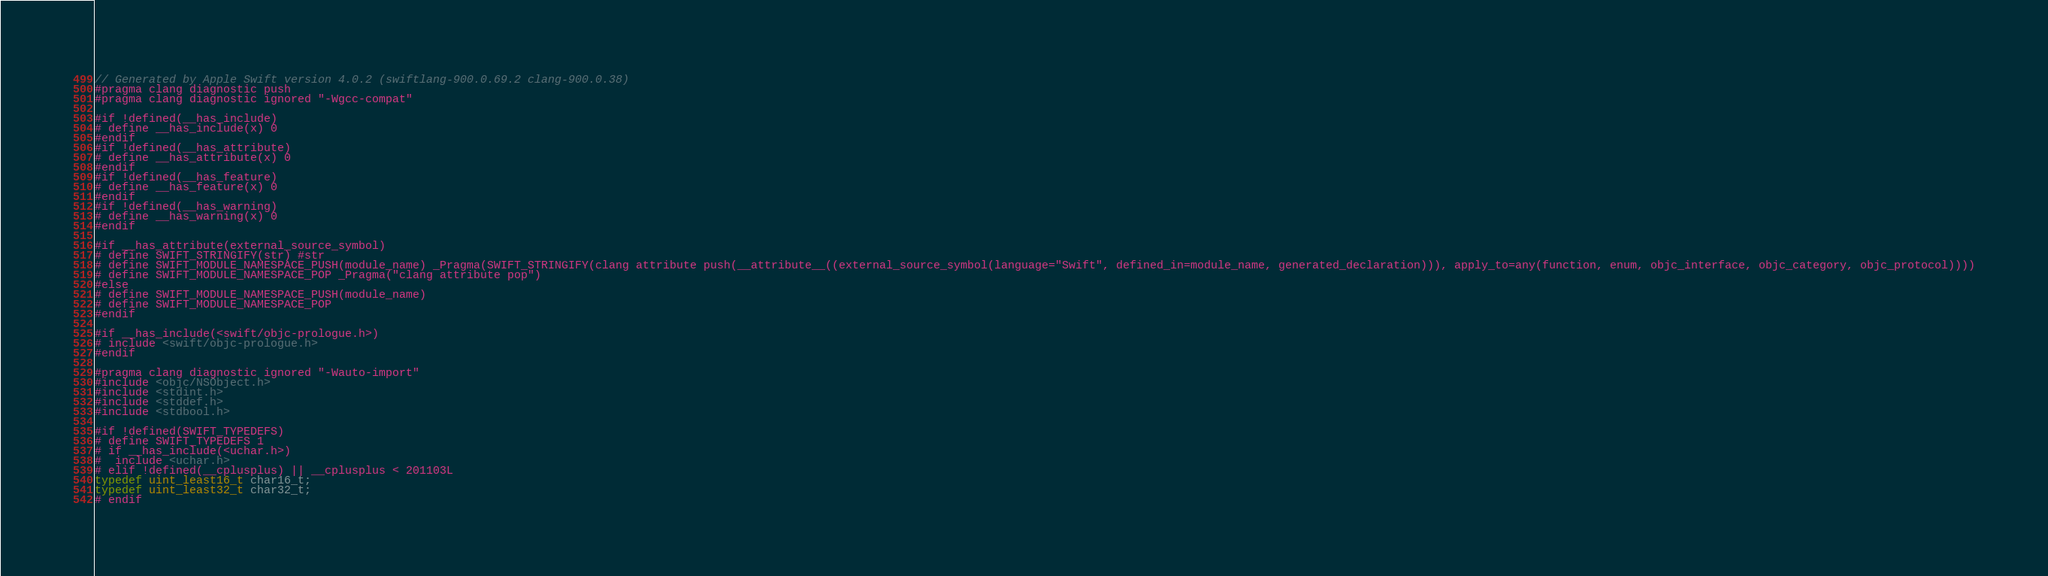Convert code to text. <code><loc_0><loc_0><loc_500><loc_500><_C_>// Generated by Apple Swift version 4.0.2 (swiftlang-900.0.69.2 clang-900.0.38)
#pragma clang diagnostic push
#pragma clang diagnostic ignored "-Wgcc-compat"

#if !defined(__has_include)
# define __has_include(x) 0
#endif
#if !defined(__has_attribute)
# define __has_attribute(x) 0
#endif
#if !defined(__has_feature)
# define __has_feature(x) 0
#endif
#if !defined(__has_warning)
# define __has_warning(x) 0
#endif

#if __has_attribute(external_source_symbol)
# define SWIFT_STRINGIFY(str) #str
# define SWIFT_MODULE_NAMESPACE_PUSH(module_name) _Pragma(SWIFT_STRINGIFY(clang attribute push(__attribute__((external_source_symbol(language="Swift", defined_in=module_name, generated_declaration))), apply_to=any(function, enum, objc_interface, objc_category, objc_protocol))))
# define SWIFT_MODULE_NAMESPACE_POP _Pragma("clang attribute pop")
#else
# define SWIFT_MODULE_NAMESPACE_PUSH(module_name)
# define SWIFT_MODULE_NAMESPACE_POP
#endif

#if __has_include(<swift/objc-prologue.h>)
# include <swift/objc-prologue.h>
#endif

#pragma clang diagnostic ignored "-Wauto-import"
#include <objc/NSObject.h>
#include <stdint.h>
#include <stddef.h>
#include <stdbool.h>

#if !defined(SWIFT_TYPEDEFS)
# define SWIFT_TYPEDEFS 1
# if __has_include(<uchar.h>)
#  include <uchar.h>
# elif !defined(__cplusplus) || __cplusplus < 201103L
typedef uint_least16_t char16_t;
typedef uint_least32_t char32_t;
# endif</code> 